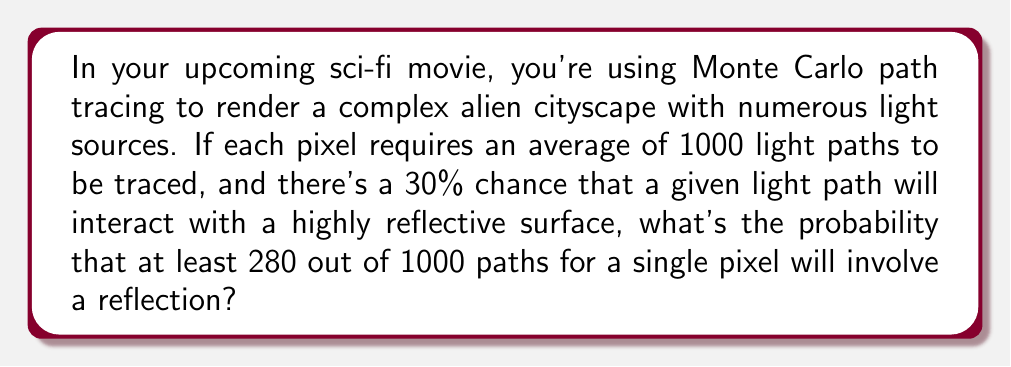Can you answer this question? Let's approach this step-by-step:

1) This scenario follows a binomial distribution. We have:
   - $n = 1000$ trials (light paths per pixel)
   - $p = 0.30$ probability of reflection for each path
   - We want to find $P(X \geq 280)$, where $X$ is the number of reflective interactions

2) The probability of at least 280 reflections is the same as 1 minus the probability of 279 or fewer reflections:

   $P(X \geq 280) = 1 - P(X \leq 279)$

3) We can use the cumulative binomial probability function:

   $P(X \leq 279) = \sum_{k=0}^{279} \binom{1000}{k} (0.30)^k (0.70)^{1000-k}$

4) This sum is computationally intensive, so we'll use the normal approximation to the binomial distribution, which is valid for large $n$ and $np > 5$, $n(1-p) > 5$ (both conditions are met here).

5) For a normal approximation:
   - Mean: $\mu = np = 1000 * 0.30 = 300$
   - Standard deviation: $\sigma = \sqrt{np(1-p)} = \sqrt{1000 * 0.30 * 0.70} = \sqrt{210} \approx 14.49$

6) We need to apply a continuity correction, so we'll use 279.5 instead of 279:

   $z = \frac{279.5 - 300}{14.49} \approx -1.41$

7) Using the standard normal distribution table or calculator:

   $P(X \leq 279) \approx P(Z \leq -1.41) \approx 0.0793$

8) Therefore:

   $P(X \geq 280) = 1 - P(X \leq 279) \approx 1 - 0.0793 = 0.9207$
Answer: $0.9207$ or $92.07\%$ 